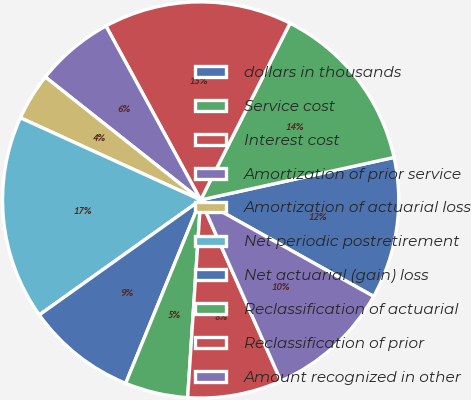Convert chart to OTSL. <chart><loc_0><loc_0><loc_500><loc_500><pie_chart><fcel>dollars in thousands<fcel>Service cost<fcel>Interest cost<fcel>Amortization of prior service<fcel>Amortization of actuarial loss<fcel>Net periodic postretirement<fcel>Net actuarial (gain) loss<fcel>Reclassification of actuarial<fcel>Reclassification of prior<fcel>Amount recognized in other<nl><fcel>11.54%<fcel>14.1%<fcel>15.38%<fcel>6.41%<fcel>3.85%<fcel>16.66%<fcel>8.97%<fcel>5.13%<fcel>7.69%<fcel>10.26%<nl></chart> 